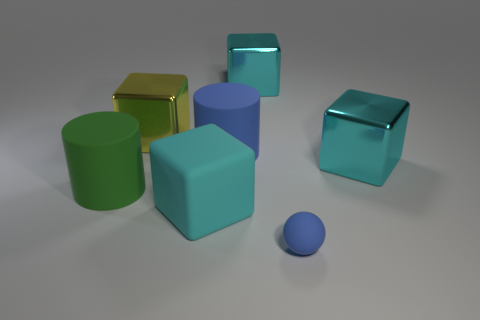Is there any other thing that has the same size as the cyan rubber block?
Give a very brief answer. Yes. How many big cyan blocks are in front of the matte cylinder right of the cyan thing in front of the green thing?
Offer a terse response. 2. Is the large green thing the same shape as the large blue matte thing?
Your answer should be compact. Yes. Are the large yellow object that is behind the big cyan rubber thing and the large cube to the right of the small object made of the same material?
Offer a very short reply. Yes. How many objects are rubber things that are right of the cyan matte object or cylinders that are to the left of the large blue thing?
Your answer should be very brief. 3. Is there anything else that is the same shape as the big yellow metallic object?
Provide a short and direct response. Yes. What number of cyan metallic cubes are there?
Offer a terse response. 2. Is there a blue sphere of the same size as the yellow metallic cube?
Ensure brevity in your answer.  No. Is the material of the small thing the same as the cyan object that is behind the large blue matte thing?
Provide a short and direct response. No. There is a cyan block behind the blue cylinder; what is it made of?
Provide a succinct answer. Metal. 